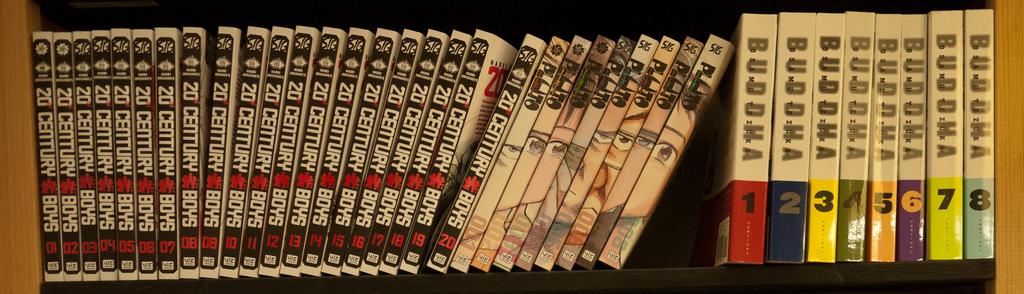What volume is the last book on the right?
Make the answer very short. 8. 